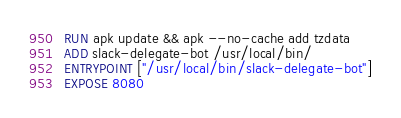<code> <loc_0><loc_0><loc_500><loc_500><_Dockerfile_>RUN apk update && apk --no-cache add tzdata
ADD slack-delegate-bot /usr/local/bin/
ENTRYPOINT ["/usr/local/bin/slack-delegate-bot"]
EXPOSE 8080
</code> 